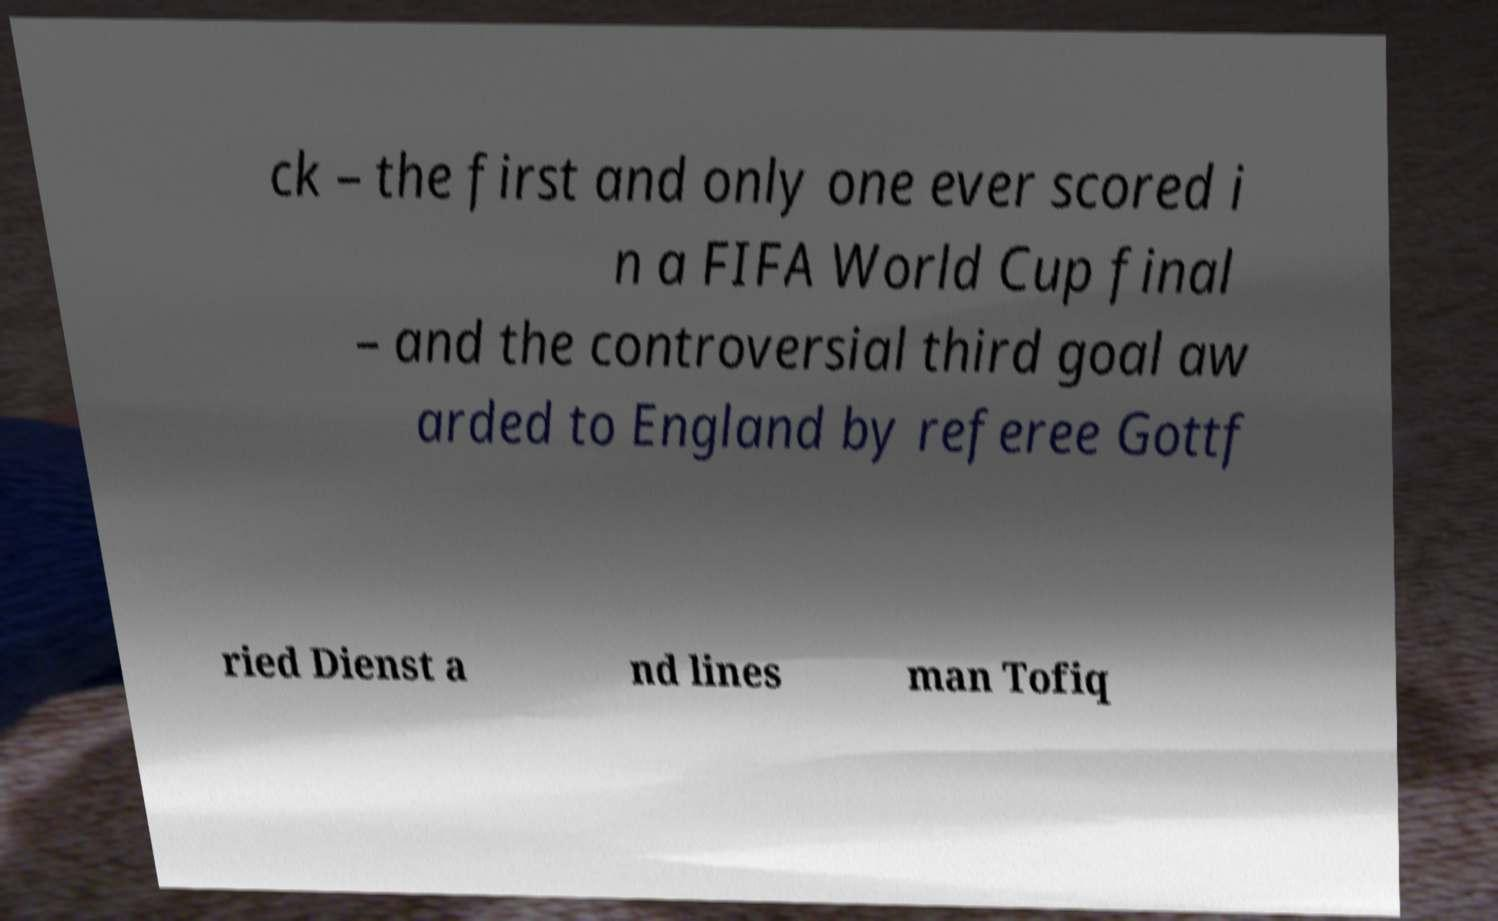Please read and relay the text visible in this image. What does it say? ck – the first and only one ever scored i n a FIFA World Cup final – and the controversial third goal aw arded to England by referee Gottf ried Dienst a nd lines man Tofiq 